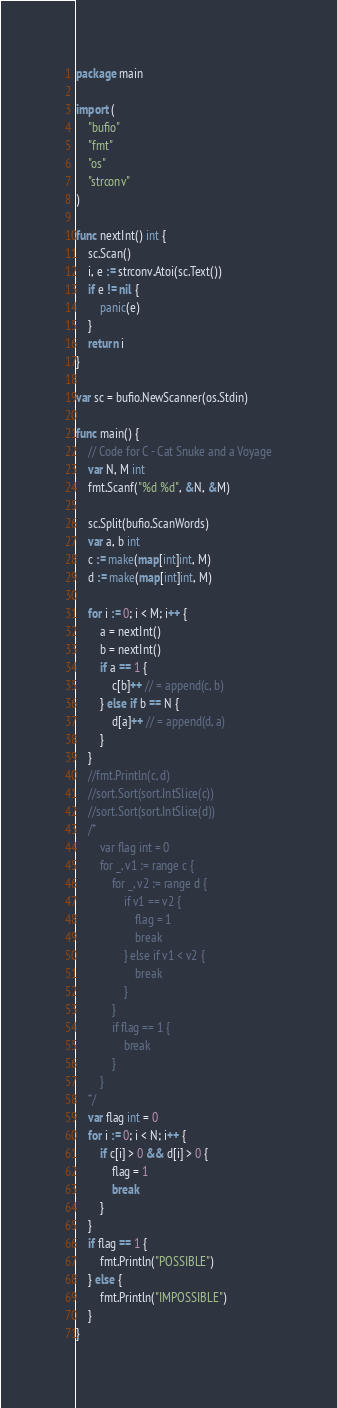<code> <loc_0><loc_0><loc_500><loc_500><_Go_>package main

import (
	"bufio"
	"fmt"
	"os"
	"strconv"
)

func nextInt() int {
	sc.Scan()
	i, e := strconv.Atoi(sc.Text())
	if e != nil {
		panic(e)
	}
	return i
}

var sc = bufio.NewScanner(os.Stdin)

func main() {
	// Code for C - Cat Snuke and a Voyage
	var N, M int
	fmt.Scanf("%d %d", &N, &M)

	sc.Split(bufio.ScanWords)
	var a, b int
	c := make(map[int]int, M)
	d := make(map[int]int, M)

	for i := 0; i < M; i++ {
		a = nextInt()
		b = nextInt()
		if a == 1 {
			c[b]++ // = append(c, b)
		} else if b == N {
			d[a]++ // = append(d, a)
		}
	}
	//fmt.Println(c, d)
	//sort.Sort(sort.IntSlice(c))
	//sort.Sort(sort.IntSlice(d))
	/*
		var flag int = 0
		for _, v1 := range c {
			for _, v2 := range d {
				if v1 == v2 {
					flag = 1
					break
				} else if v1 < v2 {
					break
				}
			}
			if flag == 1 {
				break
			}
		}
	*/
	var flag int = 0
	for i := 0; i < N; i++ {
		if c[i] > 0 && d[i] > 0 {
			flag = 1
			break
		}
	}
	if flag == 1 {
		fmt.Println("POSSIBLE")
	} else {
		fmt.Println("IMPOSSIBLE")
	}
}
</code> 